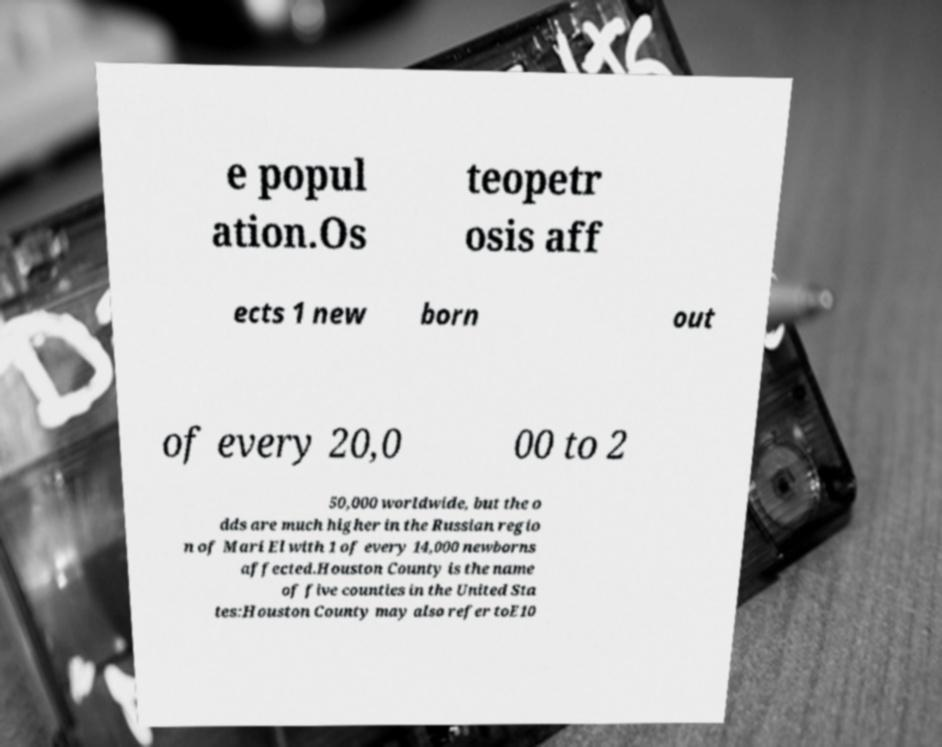What messages or text are displayed in this image? I need them in a readable, typed format. e popul ation.Os teopetr osis aff ects 1 new born out of every 20,0 00 to 2 50,000 worldwide, but the o dds are much higher in the Russian regio n of Mari El with 1 of every 14,000 newborns affected.Houston County is the name of five counties in the United Sta tes:Houston County may also refer toE10 